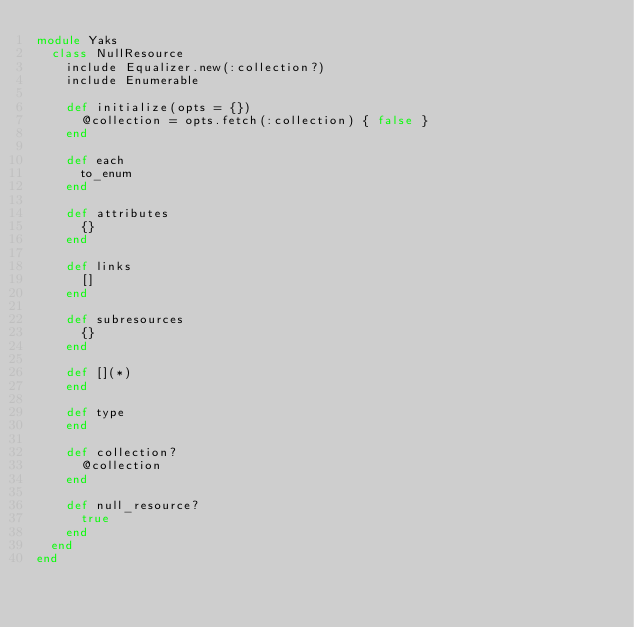<code> <loc_0><loc_0><loc_500><loc_500><_Ruby_>module Yaks
  class NullResource
    include Equalizer.new(:collection?)
    include Enumerable

    def initialize(opts = {})
      @collection = opts.fetch(:collection) { false }
    end

    def each
      to_enum
    end

    def attributes
      {}
    end

    def links
      []
    end

    def subresources
      {}
    end

    def [](*)
    end

    def type
    end

    def collection?
      @collection
    end

    def null_resource?
      true
    end
  end
end
</code> 